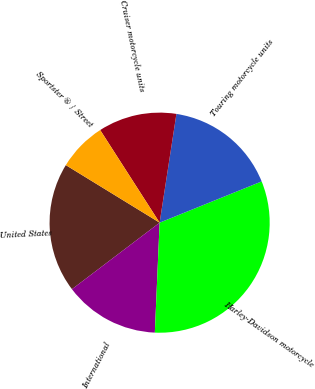Convert chart. <chart><loc_0><loc_0><loc_500><loc_500><pie_chart><fcel>United States<fcel>International<fcel>Harley-Davidson motorcycle<fcel>Touring motorcycle units<fcel>Cruiser motorcycle units<fcel>Sportster ® / Street<nl><fcel>19.09%<fcel>13.98%<fcel>31.81%<fcel>16.45%<fcel>11.52%<fcel>7.16%<nl></chart> 